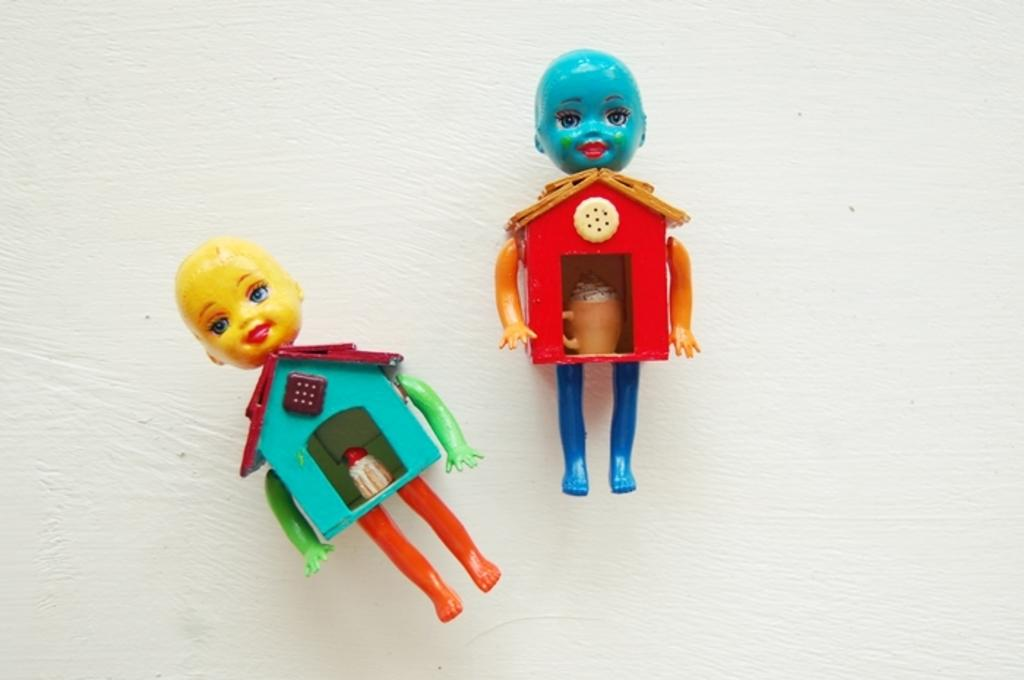What objects are present in the image? There are two toys in the image. What is the color of the surface on which the toys are placed? The toys are on a white surface. What type of meat is being smashed by the toys in the image? There is no meat present in the image, and the toys are not smashing anything. 